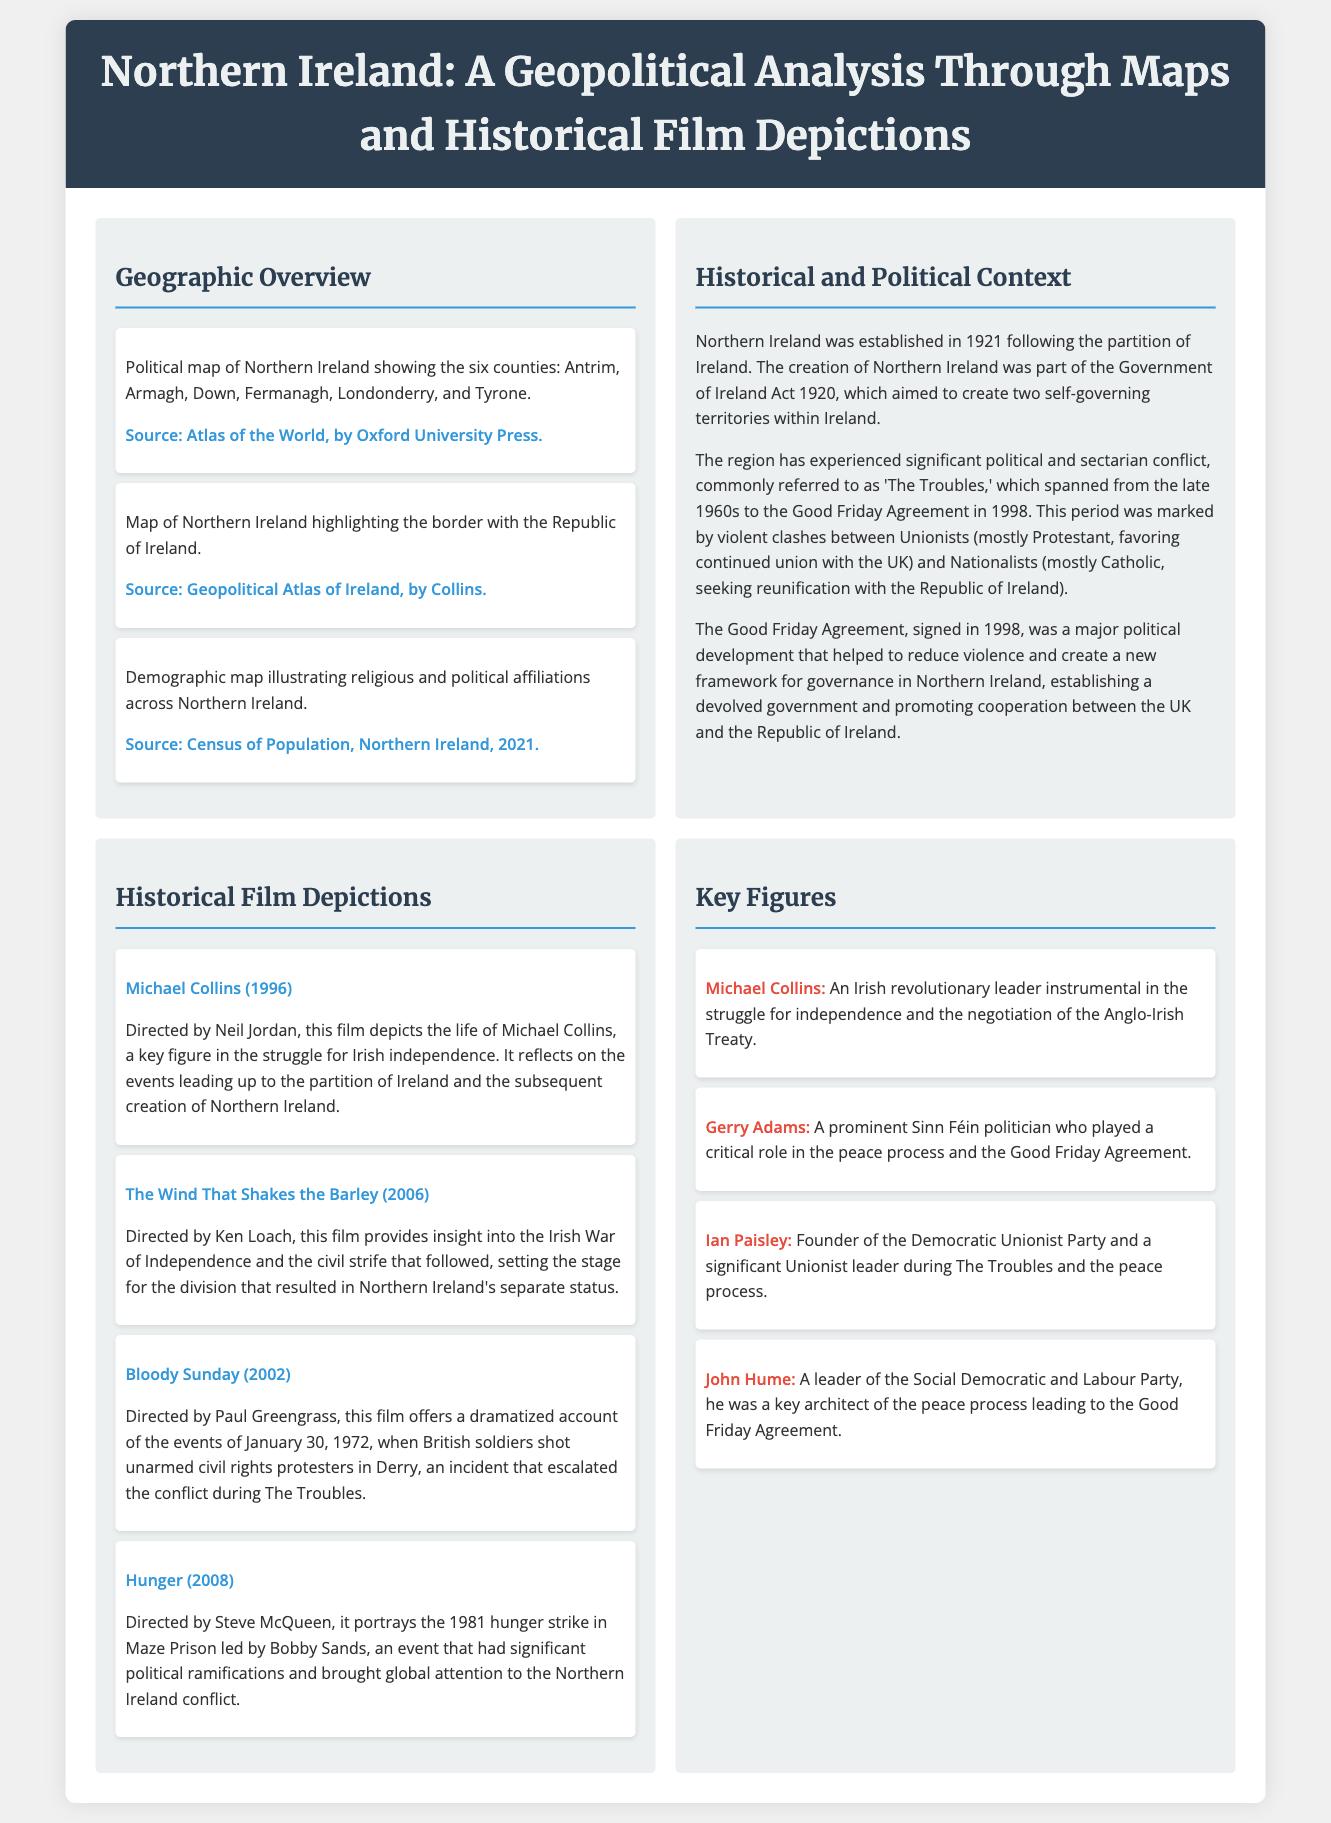What year was Northern Ireland established? Northern Ireland was established in 1921 following the partition of Ireland.
Answer: 1921 How many counties are in Northern Ireland? The political map of Northern Ireland shows six counties: Antrim, Armagh, Down, Fermanagh, Londonderry, and Tyrone.
Answer: Six Which film depicts the events of Bloody Sunday? The film "Bloody Sunday" dramatizes the events of January 30, 1972.
Answer: Bloody Sunday What agreement significantly reduced violence in Northern Ireland? The Good Friday Agreement, signed in 1998, was a major political development that helped to reduce violence.
Answer: Good Friday Agreement Who directed the film "The Wind That Shakes the Barley"? The Wind That Shakes the Barley was directed by Ken Loach.
Answer: Ken Loach Which political figure is associated with the Democratic Unionist Party? Ian Paisley is the founder of the Democratic Unionist Party and a significant Unionist leader.
Answer: Ian Paisley What type of map illustrates religious and political affiliations in Northern Ireland? A demographic map illustrates religious and political affiliations across Northern Ireland.
Answer: Demographic map Who played a critical role in the peace process and the Good Friday Agreement? Gerry Adams is a prominent Sinn Féin politician who played a critical role in the peace process.
Answer: Gerry Adams What resource illustrates the border between Northern Ireland and the Republic of Ireland? The map highlighting the border with the Republic of Ireland serves as a geographic overview of that relationship.
Answer: Map of Northern Ireland 